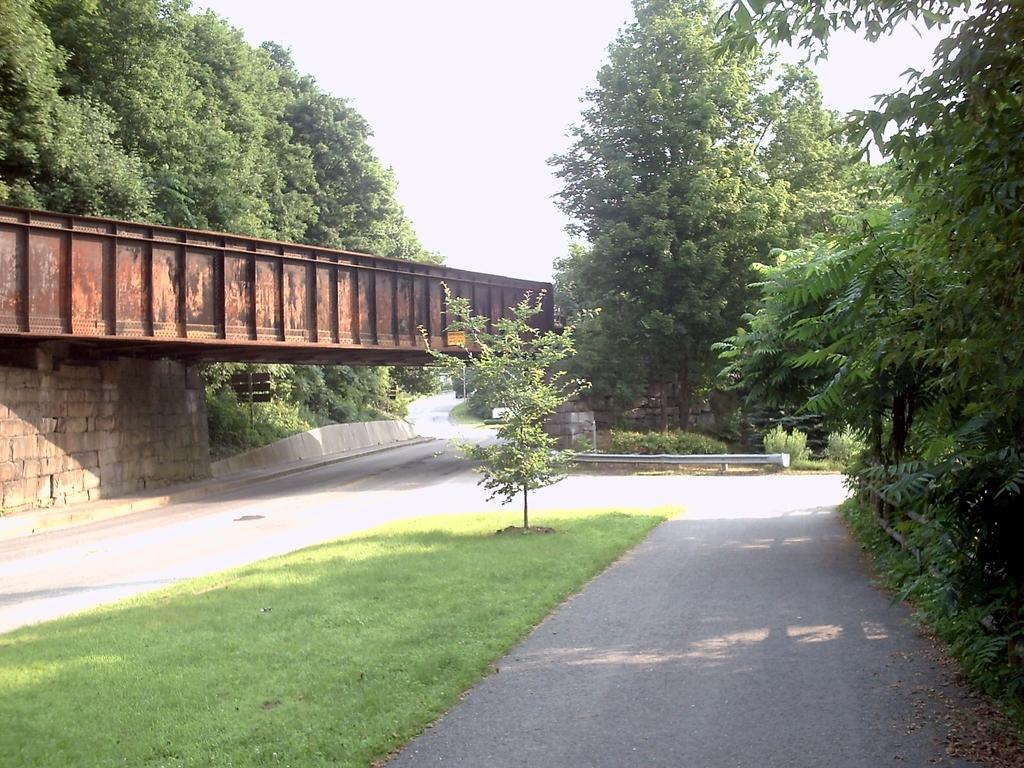Describe this image in one or two sentences. In this picture there are trees. On the left side of the image there is a bridge and there is a pole. At the top there is sky. At the bottom there is a road and there is grass. 